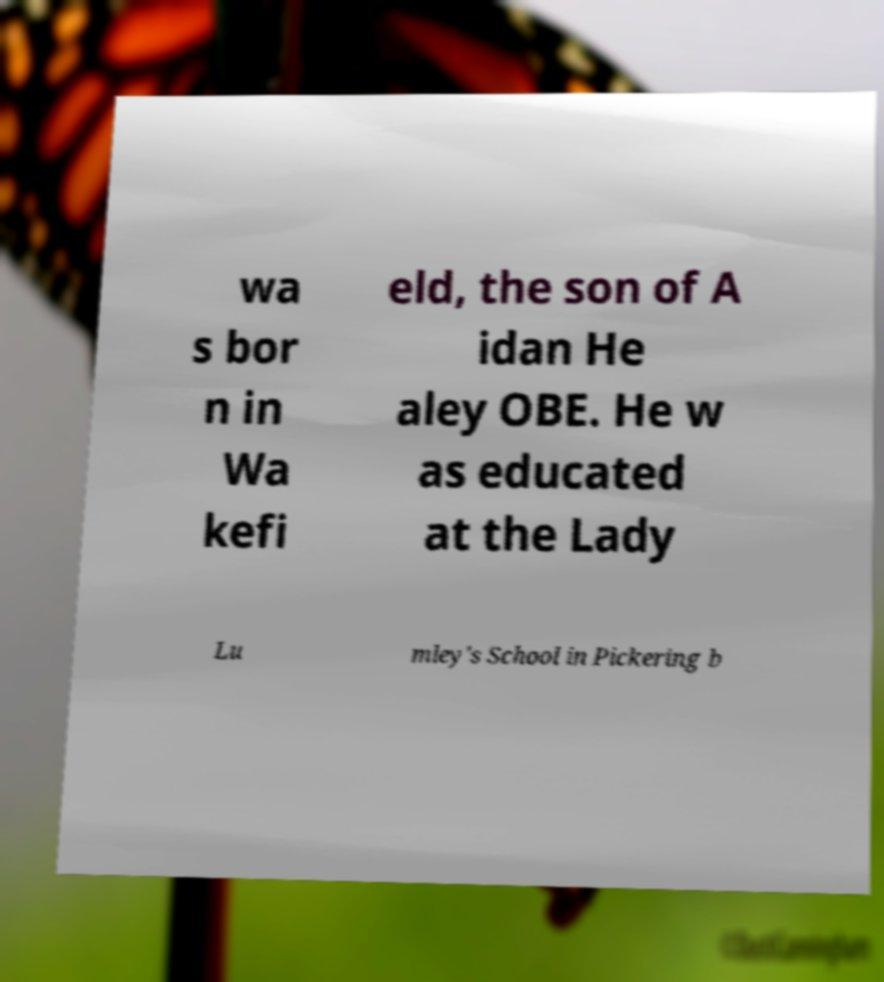Could you extract and type out the text from this image? wa s bor n in Wa kefi eld, the son of A idan He aley OBE. He w as educated at the Lady Lu mley's School in Pickering b 